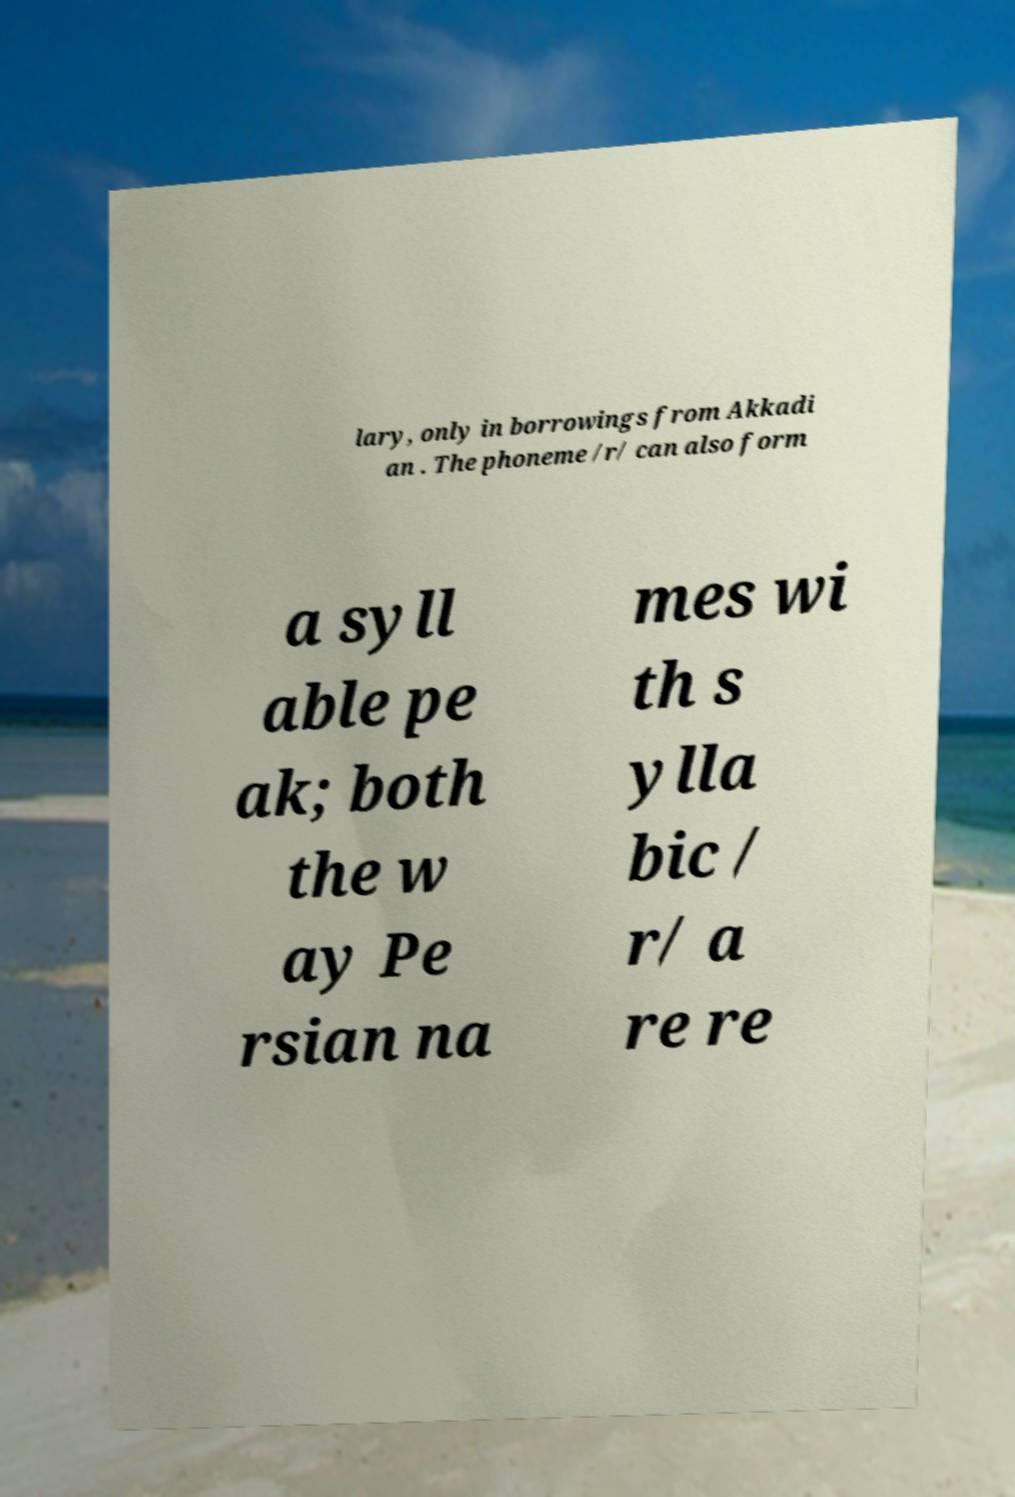For documentation purposes, I need the text within this image transcribed. Could you provide that? lary, only in borrowings from Akkadi an . The phoneme /r/ can also form a syll able pe ak; both the w ay Pe rsian na mes wi th s ylla bic / r/ a re re 